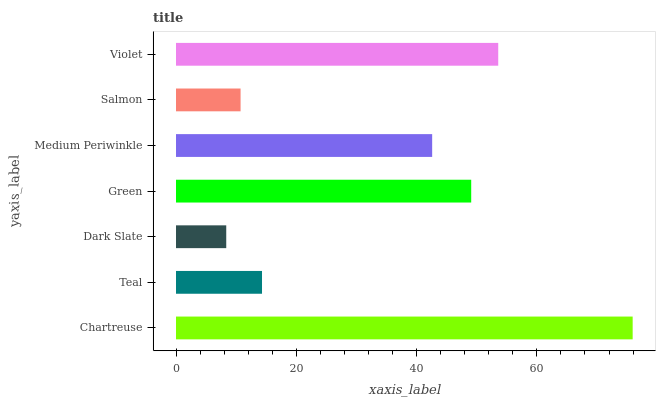Is Dark Slate the minimum?
Answer yes or no. Yes. Is Chartreuse the maximum?
Answer yes or no. Yes. Is Teal the minimum?
Answer yes or no. No. Is Teal the maximum?
Answer yes or no. No. Is Chartreuse greater than Teal?
Answer yes or no. Yes. Is Teal less than Chartreuse?
Answer yes or no. Yes. Is Teal greater than Chartreuse?
Answer yes or no. No. Is Chartreuse less than Teal?
Answer yes or no. No. Is Medium Periwinkle the high median?
Answer yes or no. Yes. Is Medium Periwinkle the low median?
Answer yes or no. Yes. Is Teal the high median?
Answer yes or no. No. Is Chartreuse the low median?
Answer yes or no. No. 